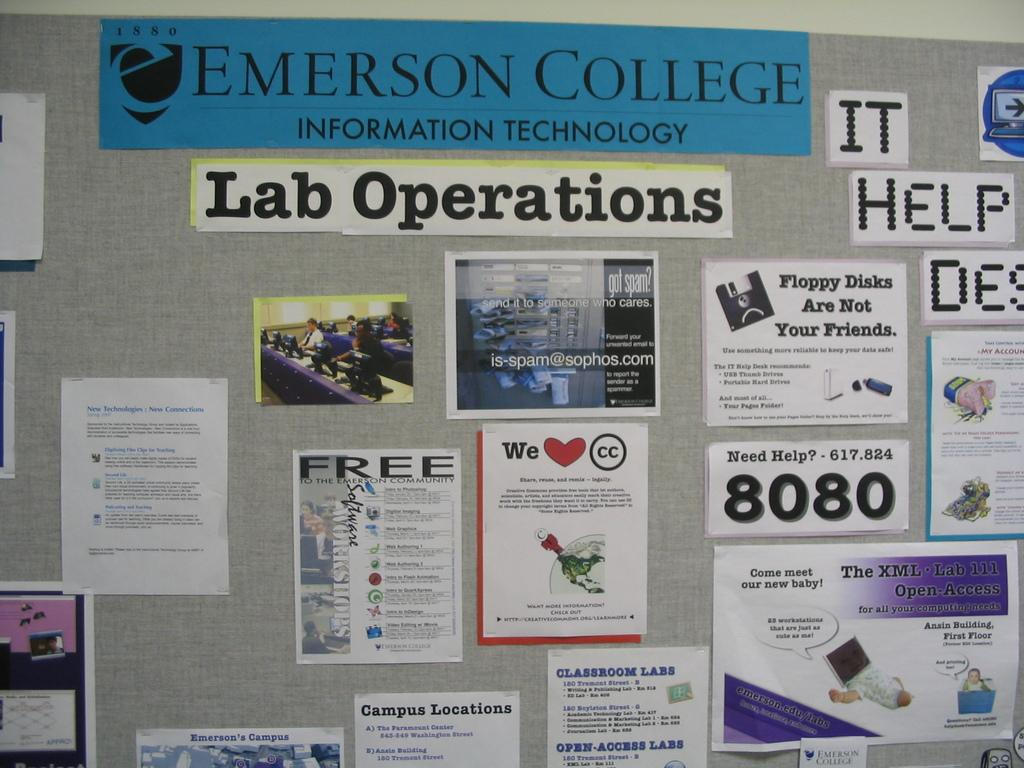Provide a one-sentence caption for the provided image. A wall in a building at Emerson College displays a number of posters and messages. 